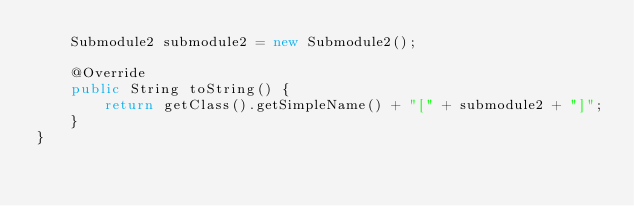Convert code to text. <code><loc_0><loc_0><loc_500><loc_500><_Java_>    Submodule2 submodule2 = new Submodule2();

    @Override
    public String toString() {
        return getClass().getSimpleName() + "[" + submodule2 + "]";
    }
}
</code> 